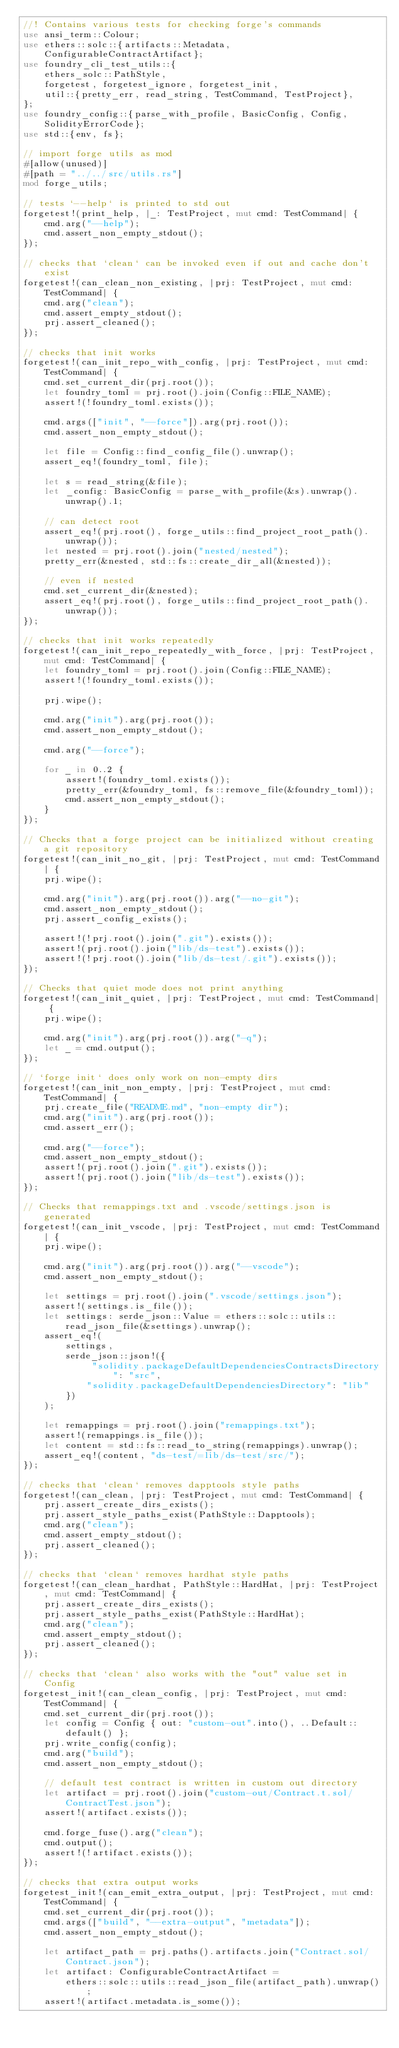<code> <loc_0><loc_0><loc_500><loc_500><_Rust_>//! Contains various tests for checking forge's commands
use ansi_term::Colour;
use ethers::solc::{artifacts::Metadata, ConfigurableContractArtifact};
use foundry_cli_test_utils::{
    ethers_solc::PathStyle,
    forgetest, forgetest_ignore, forgetest_init,
    util::{pretty_err, read_string, TestCommand, TestProject},
};
use foundry_config::{parse_with_profile, BasicConfig, Config, SolidityErrorCode};
use std::{env, fs};

// import forge utils as mod
#[allow(unused)]
#[path = "../../src/utils.rs"]
mod forge_utils;

// tests `--help` is printed to std out
forgetest!(print_help, |_: TestProject, mut cmd: TestCommand| {
    cmd.arg("--help");
    cmd.assert_non_empty_stdout();
});

// checks that `clean` can be invoked even if out and cache don't exist
forgetest!(can_clean_non_existing, |prj: TestProject, mut cmd: TestCommand| {
    cmd.arg("clean");
    cmd.assert_empty_stdout();
    prj.assert_cleaned();
});

// checks that init works
forgetest!(can_init_repo_with_config, |prj: TestProject, mut cmd: TestCommand| {
    cmd.set_current_dir(prj.root());
    let foundry_toml = prj.root().join(Config::FILE_NAME);
    assert!(!foundry_toml.exists());

    cmd.args(["init", "--force"]).arg(prj.root());
    cmd.assert_non_empty_stdout();

    let file = Config::find_config_file().unwrap();
    assert_eq!(foundry_toml, file);

    let s = read_string(&file);
    let _config: BasicConfig = parse_with_profile(&s).unwrap().unwrap().1;

    // can detect root
    assert_eq!(prj.root(), forge_utils::find_project_root_path().unwrap());
    let nested = prj.root().join("nested/nested");
    pretty_err(&nested, std::fs::create_dir_all(&nested));

    // even if nested
    cmd.set_current_dir(&nested);
    assert_eq!(prj.root(), forge_utils::find_project_root_path().unwrap());
});

// checks that init works repeatedly
forgetest!(can_init_repo_repeatedly_with_force, |prj: TestProject, mut cmd: TestCommand| {
    let foundry_toml = prj.root().join(Config::FILE_NAME);
    assert!(!foundry_toml.exists());

    prj.wipe();

    cmd.arg("init").arg(prj.root());
    cmd.assert_non_empty_stdout();

    cmd.arg("--force");

    for _ in 0..2 {
        assert!(foundry_toml.exists());
        pretty_err(&foundry_toml, fs::remove_file(&foundry_toml));
        cmd.assert_non_empty_stdout();
    }
});

// Checks that a forge project can be initialized without creating a git repository
forgetest!(can_init_no_git, |prj: TestProject, mut cmd: TestCommand| {
    prj.wipe();

    cmd.arg("init").arg(prj.root()).arg("--no-git");
    cmd.assert_non_empty_stdout();
    prj.assert_config_exists();

    assert!(!prj.root().join(".git").exists());
    assert!(prj.root().join("lib/ds-test").exists());
    assert!(!prj.root().join("lib/ds-test/.git").exists());
});

// Checks that quiet mode does not print anything
forgetest!(can_init_quiet, |prj: TestProject, mut cmd: TestCommand| {
    prj.wipe();

    cmd.arg("init").arg(prj.root()).arg("-q");
    let _ = cmd.output();
});

// `forge init` does only work on non-empty dirs
forgetest!(can_init_non_empty, |prj: TestProject, mut cmd: TestCommand| {
    prj.create_file("README.md", "non-empty dir");
    cmd.arg("init").arg(prj.root());
    cmd.assert_err();

    cmd.arg("--force");
    cmd.assert_non_empty_stdout();
    assert!(prj.root().join(".git").exists());
    assert!(prj.root().join("lib/ds-test").exists());
});

// Checks that remappings.txt and .vscode/settings.json is generated
forgetest!(can_init_vscode, |prj: TestProject, mut cmd: TestCommand| {
    prj.wipe();

    cmd.arg("init").arg(prj.root()).arg("--vscode");
    cmd.assert_non_empty_stdout();

    let settings = prj.root().join(".vscode/settings.json");
    assert!(settings.is_file());
    let settings: serde_json::Value = ethers::solc::utils::read_json_file(&settings).unwrap();
    assert_eq!(
        settings,
        serde_json::json!({
             "solidity.packageDefaultDependenciesContractsDirectory": "src",
            "solidity.packageDefaultDependenciesDirectory": "lib"
        })
    );

    let remappings = prj.root().join("remappings.txt");
    assert!(remappings.is_file());
    let content = std::fs::read_to_string(remappings).unwrap();
    assert_eq!(content, "ds-test/=lib/ds-test/src/");
});

// checks that `clean` removes dapptools style paths
forgetest!(can_clean, |prj: TestProject, mut cmd: TestCommand| {
    prj.assert_create_dirs_exists();
    prj.assert_style_paths_exist(PathStyle::Dapptools);
    cmd.arg("clean");
    cmd.assert_empty_stdout();
    prj.assert_cleaned();
});

// checks that `clean` removes hardhat style paths
forgetest!(can_clean_hardhat, PathStyle::HardHat, |prj: TestProject, mut cmd: TestCommand| {
    prj.assert_create_dirs_exists();
    prj.assert_style_paths_exist(PathStyle::HardHat);
    cmd.arg("clean");
    cmd.assert_empty_stdout();
    prj.assert_cleaned();
});

// checks that `clean` also works with the "out" value set in Config
forgetest_init!(can_clean_config, |prj: TestProject, mut cmd: TestCommand| {
    cmd.set_current_dir(prj.root());
    let config = Config { out: "custom-out".into(), ..Default::default() };
    prj.write_config(config);
    cmd.arg("build");
    cmd.assert_non_empty_stdout();

    // default test contract is written in custom out directory
    let artifact = prj.root().join("custom-out/Contract.t.sol/ContractTest.json");
    assert!(artifact.exists());

    cmd.forge_fuse().arg("clean");
    cmd.output();
    assert!(!artifact.exists());
});

// checks that extra output works
forgetest_init!(can_emit_extra_output, |prj: TestProject, mut cmd: TestCommand| {
    cmd.set_current_dir(prj.root());
    cmd.args(["build", "--extra-output", "metadata"]);
    cmd.assert_non_empty_stdout();

    let artifact_path = prj.paths().artifacts.join("Contract.sol/Contract.json");
    let artifact: ConfigurableContractArtifact =
        ethers::solc::utils::read_json_file(artifact_path).unwrap();
    assert!(artifact.metadata.is_some());
</code> 